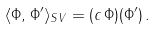Convert formula to latex. <formula><loc_0><loc_0><loc_500><loc_500>\langle \Phi , \Phi ^ { \prime } \rangle _ { S V } = ( c \, \Phi ) ( \Phi ^ { \prime } ) \, .</formula> 